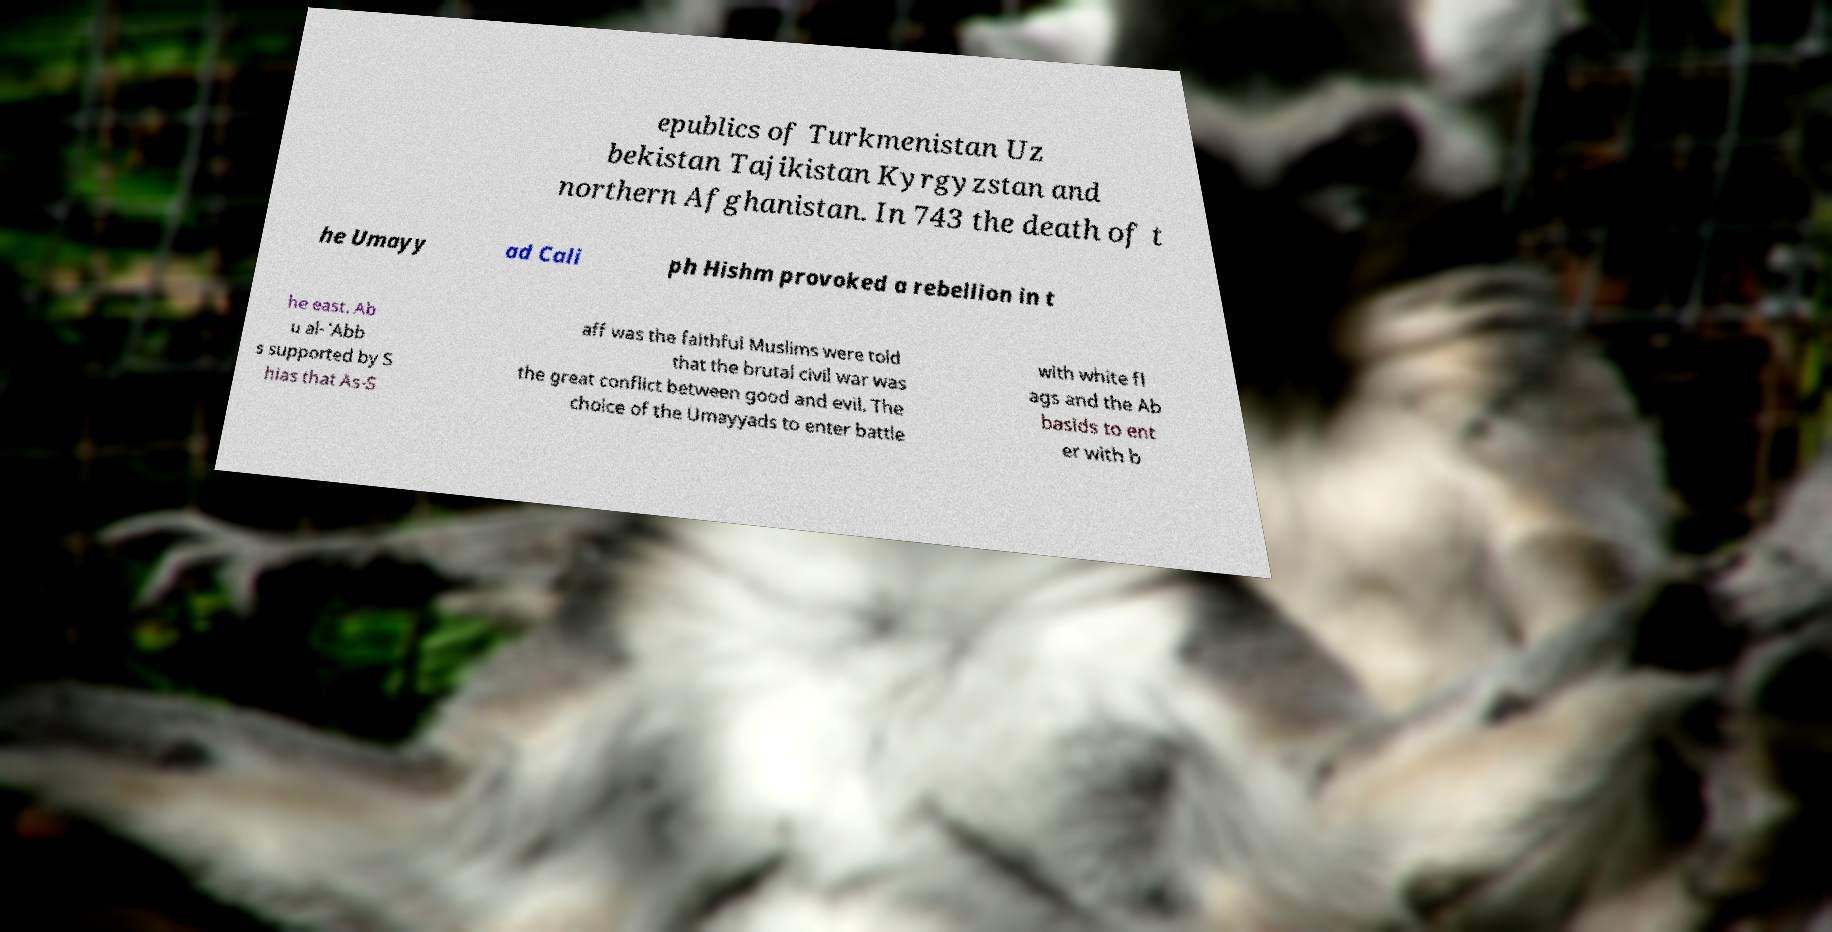Could you extract and type out the text from this image? epublics of Turkmenistan Uz bekistan Tajikistan Kyrgyzstan and northern Afghanistan. In 743 the death of t he Umayy ad Cali ph Hishm provoked a rebellion in t he east. Ab u al-`Abb s supported by S hias that As-S aff was the faithful Muslims were told that the brutal civil war was the great conflict between good and evil. The choice of the Umayyads to enter battle with white fl ags and the Ab basids to ent er with b 